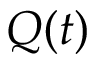<formula> <loc_0><loc_0><loc_500><loc_500>Q ( t )</formula> 